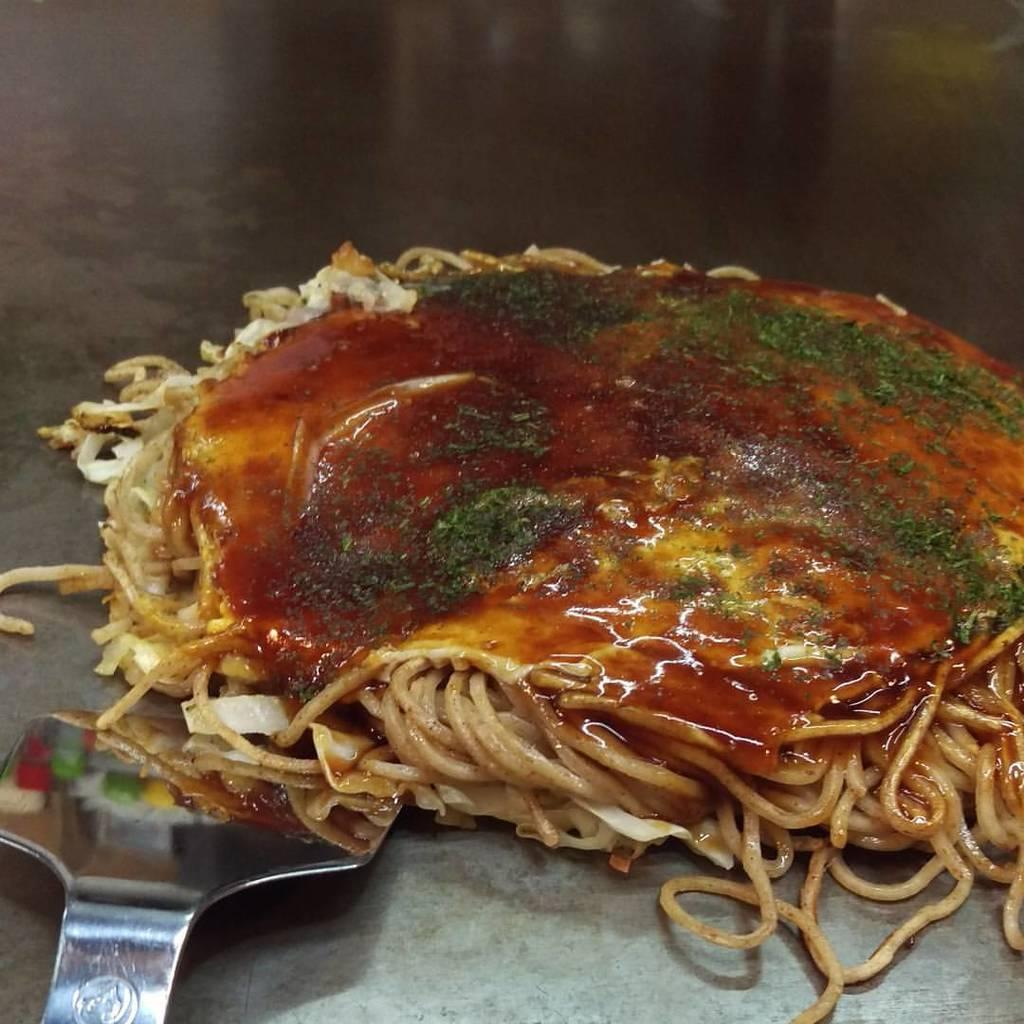What is present in the image related to cooking or food preparation? There is food and a spatula in the image. On what surface are the food and spatula located? The food and spatula are present on a surface. What language is being spoken by the babies in the image? There are no babies present in the image, so it is not possible to determine what language they might be speaking. 